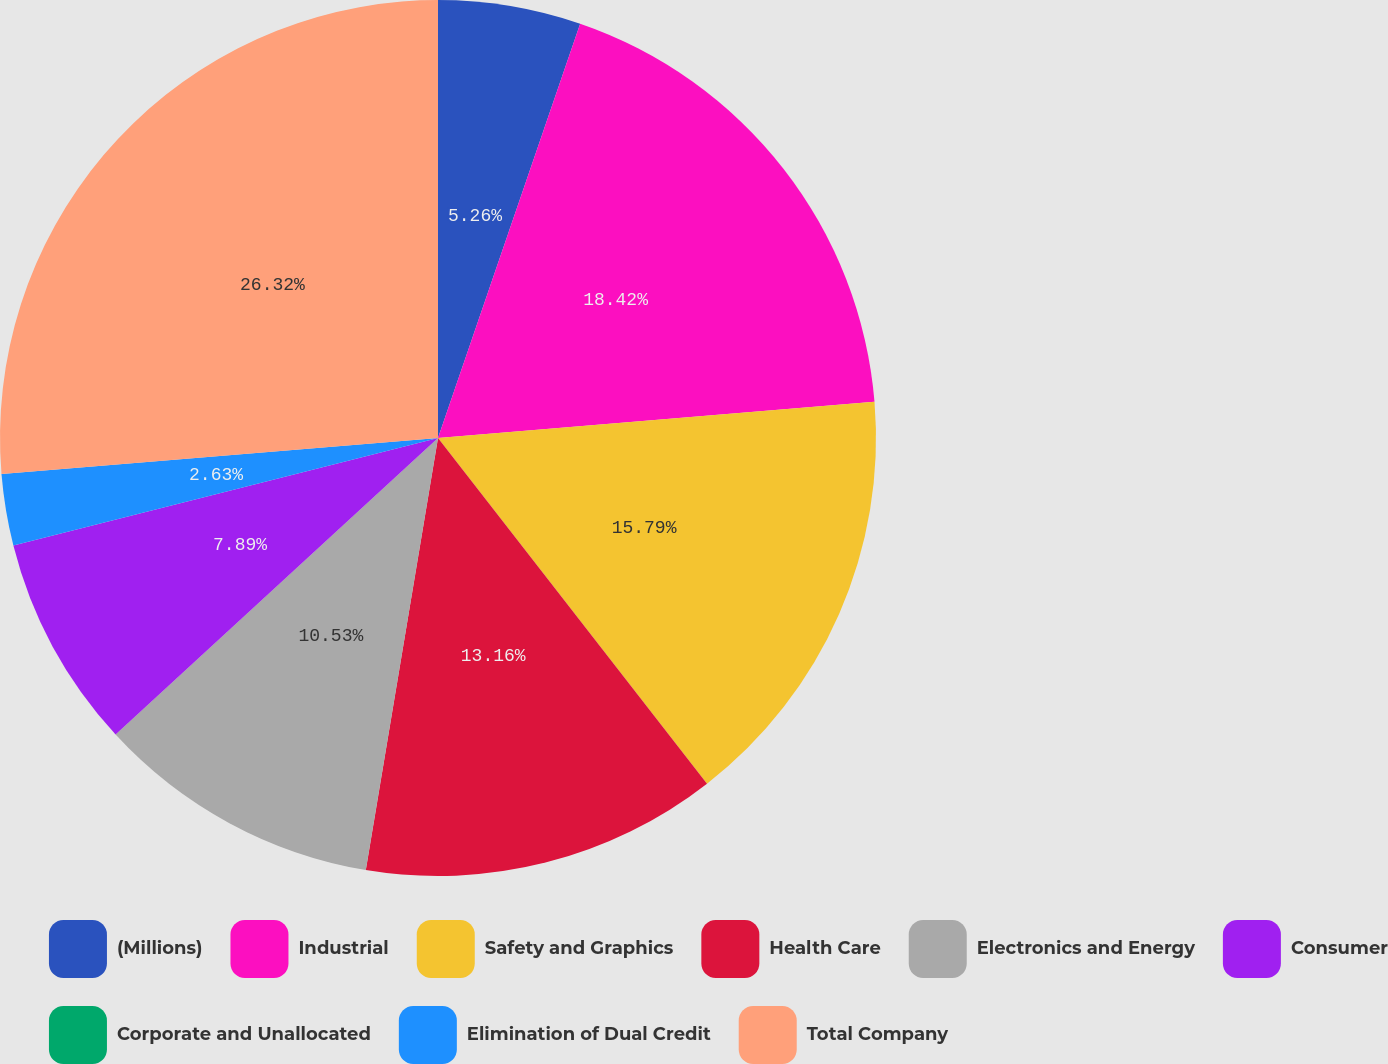Convert chart to OTSL. <chart><loc_0><loc_0><loc_500><loc_500><pie_chart><fcel>(Millions)<fcel>Industrial<fcel>Safety and Graphics<fcel>Health Care<fcel>Electronics and Energy<fcel>Consumer<fcel>Corporate and Unallocated<fcel>Elimination of Dual Credit<fcel>Total Company<nl><fcel>5.26%<fcel>18.42%<fcel>15.79%<fcel>13.16%<fcel>10.53%<fcel>7.89%<fcel>0.0%<fcel>2.63%<fcel>26.31%<nl></chart> 